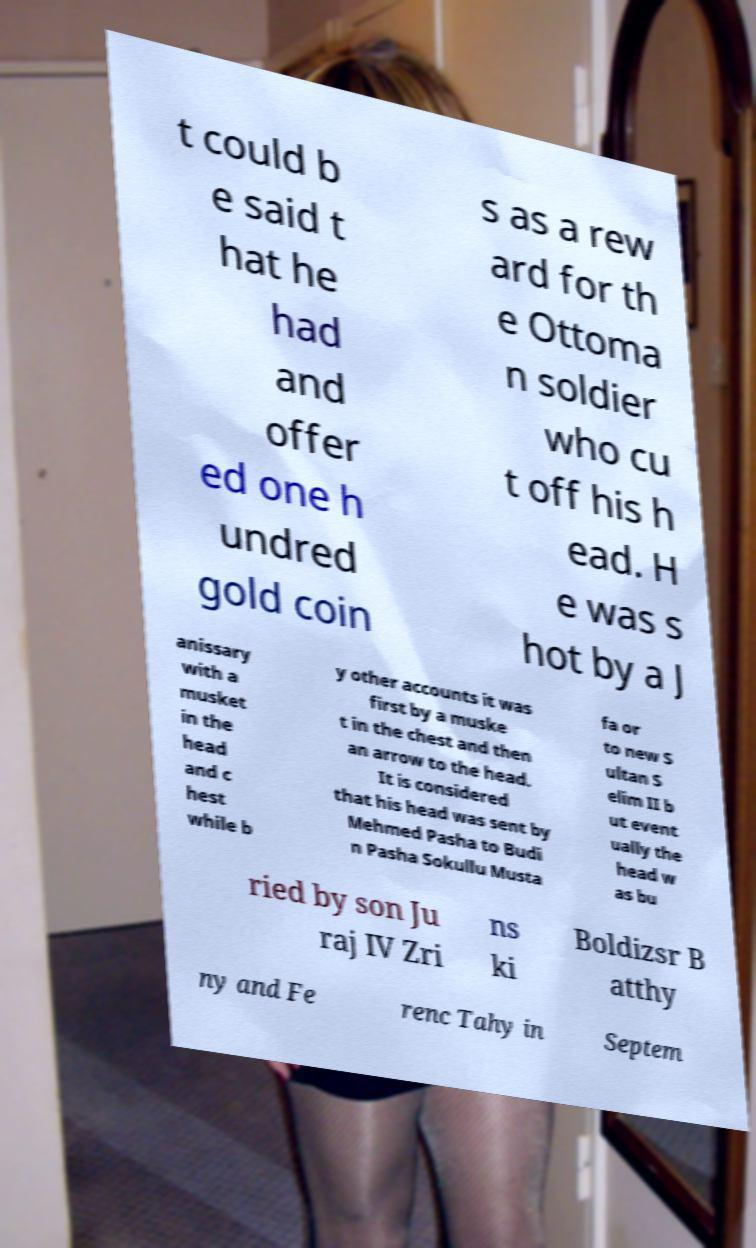Could you extract and type out the text from this image? t could b e said t hat he had and offer ed one h undred gold coin s as a rew ard for th e Ottoma n soldier who cu t off his h ead. H e was s hot by a J anissary with a musket in the head and c hest while b y other accounts it was first by a muske t in the chest and then an arrow to the head. It is considered that his head was sent by Mehmed Pasha to Budi n Pasha Sokullu Musta fa or to new S ultan S elim II b ut event ually the head w as bu ried by son Ju raj IV Zri ns ki Boldizsr B atthy ny and Fe renc Tahy in Septem 